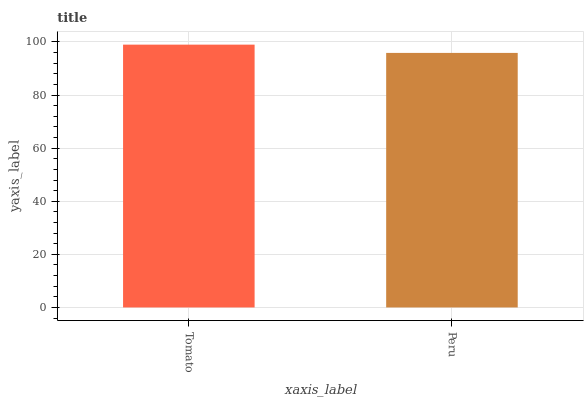Is Peru the minimum?
Answer yes or no. Yes. Is Tomato the maximum?
Answer yes or no. Yes. Is Peru the maximum?
Answer yes or no. No. Is Tomato greater than Peru?
Answer yes or no. Yes. Is Peru less than Tomato?
Answer yes or no. Yes. Is Peru greater than Tomato?
Answer yes or no. No. Is Tomato less than Peru?
Answer yes or no. No. Is Tomato the high median?
Answer yes or no. Yes. Is Peru the low median?
Answer yes or no. Yes. Is Peru the high median?
Answer yes or no. No. Is Tomato the low median?
Answer yes or no. No. 